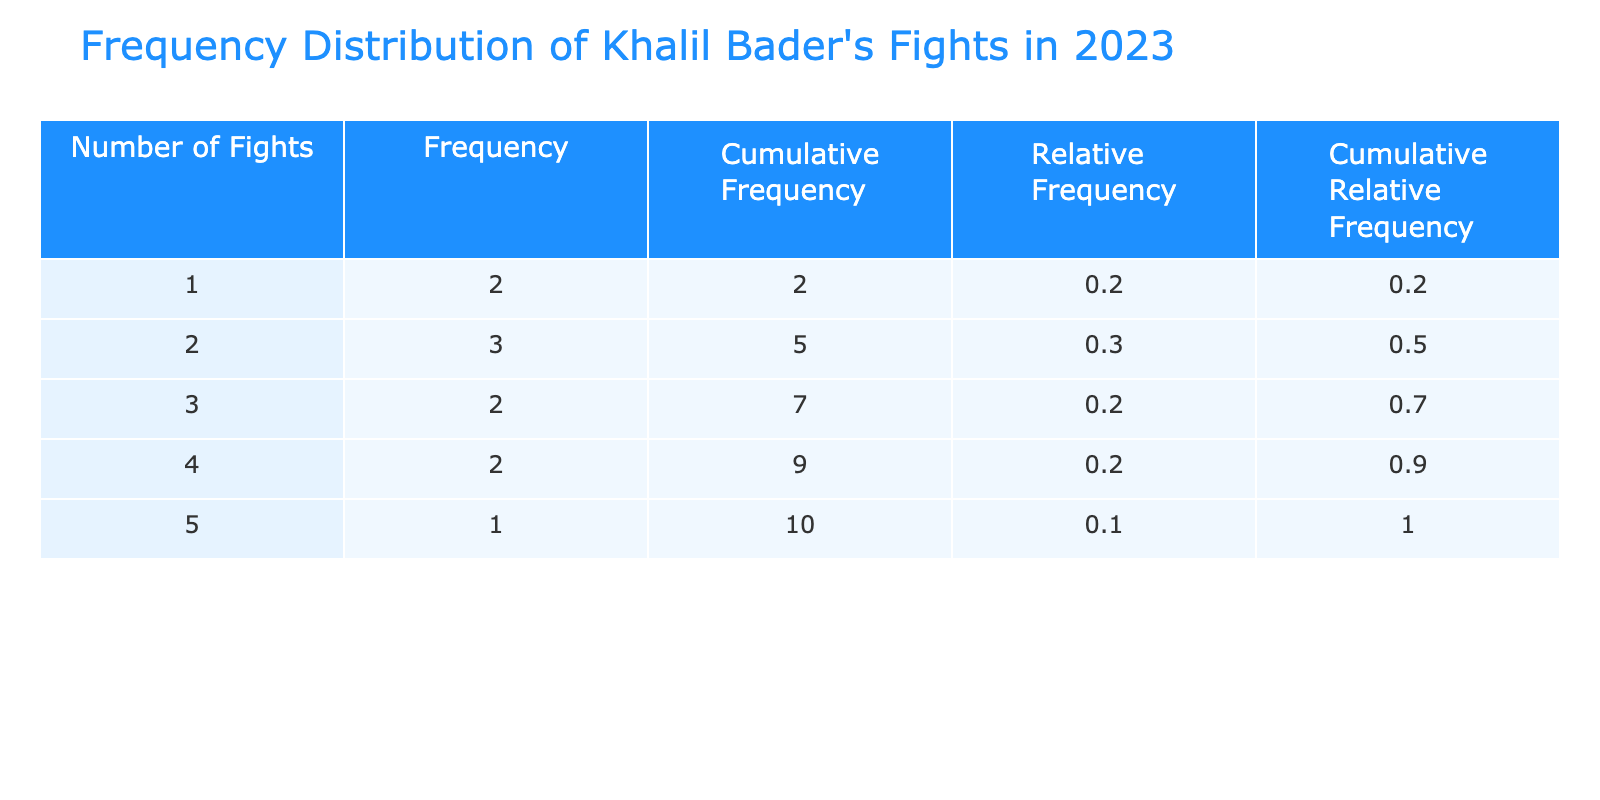What month had the highest number of fights? July has the highest number of fights with a total of 5. This was determined by looking at the 'Number of Fights' column and identifying the maximum value.
Answer: July What is the cumulative frequency of fights by April? By April, there were a total of 8 fights. The cumulative frequency is found by adding the number of fights from January (2), February (1), March (3), and April (2), i.e., 2 + 1 + 3 + 2 = 8.
Answer: 8 Did Khalil Bader have more than 3 fights in August? No, he had 3 fights in August, which is not more than 3. This can be confirmed by directly reading the number of fights listed for August in the table.
Answer: No What is the average number of fights Khalil Bader participated in during the first half of 2023? The average is calculated using the fights in January (2), February (1), March (3), April (2), May (4), and June (1). There are 6 months, and the sum of fights is 13 (2 + 1 + 3 + 2 + 4 + 1). Thus, the average is 13/6 = 2.17.
Answer: 2.17 What was the relative frequency of months with 2 fights? The relative frequency for months with 2 fights can be calculated based on the appearance of 2 in the 'Number of Fights' column, which occurs 3 times (January, April, September). The total fights across all months is 19 (2 + 1 + 3 + 2 + 4 + 1 + 5 + 3 + 2 + 4), thus the relative frequency is 3/10 = 0.3 or 30%.
Answer: 0.3 What was the cumulative relative frequency of fighters by September? The cumulative relative frequency includes calculations until September. At this point, there were 19 total fights and the cumulative frequencies are obtained by summing the relative frequencies for each month up to September, leading to a cumulative relative frequency of approximately 0.84.
Answer: 0.84 How many months had Khalil Bader participated in fewer than 3 fights? Four months had fewer than 3 fights: January (2), February (1), June (1), and September (2). Therefore, there were 4 months in total fitting this criteria.
Answer: 4 Were there any months where Khalil Bader participated in exactly 1 fight? Yes, there were 2 months (February and June) where Khalil Bader had exactly 1 fight. This is verified directly from the table where these values are listed.
Answer: Yes 